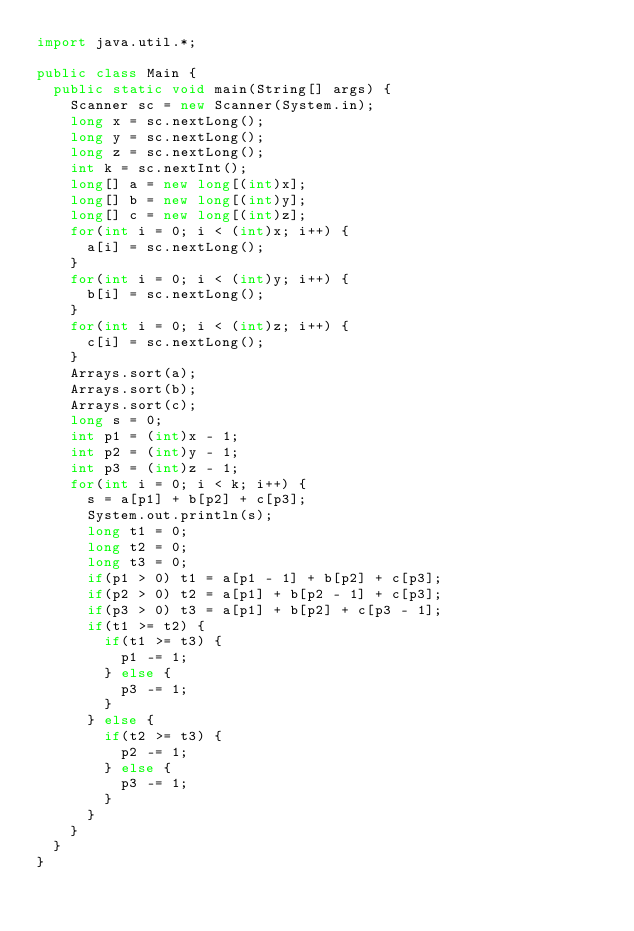Convert code to text. <code><loc_0><loc_0><loc_500><loc_500><_Java_>import java.util.*;

public class Main {
  public static void main(String[] args) {
    Scanner sc = new Scanner(System.in);
    long x = sc.nextLong();
    long y = sc.nextLong();
    long z = sc.nextLong();
    int k = sc.nextInt();
    long[] a = new long[(int)x];
    long[] b = new long[(int)y];
    long[] c = new long[(int)z];
    for(int i = 0; i < (int)x; i++) {
      a[i] = sc.nextLong();
    }
    for(int i = 0; i < (int)y; i++) {
      b[i] = sc.nextLong();
    }
    for(int i = 0; i < (int)z; i++) {
      c[i] = sc.nextLong();
    }
    Arrays.sort(a);
    Arrays.sort(b);
    Arrays.sort(c);
    long s = 0;
    int p1 = (int)x - 1;
    int p2 = (int)y - 1;
    int p3 = (int)z - 1;
    for(int i = 0; i < k; i++) {
      s = a[p1] + b[p2] + c[p3];
      System.out.println(s);
      long t1 = 0;
      long t2 = 0;
      long t3 = 0;
      if(p1 > 0) t1 = a[p1 - 1] + b[p2] + c[p3];
      if(p2 > 0) t2 = a[p1] + b[p2 - 1] + c[p3];
      if(p3 > 0) t3 = a[p1] + b[p2] + c[p3 - 1];
      if(t1 >= t2) {
        if(t1 >= t3) {
          p1 -= 1;
        } else {
          p3 -= 1;
        }
      } else {
        if(t2 >= t3) {
          p2 -= 1;
        } else {
          p3 -= 1;
        }
      }
    }
  }
}</code> 